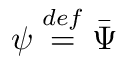<formula> <loc_0><loc_0><loc_500><loc_500>\psi { \stackrel { \ r { d e f } } { = } } \bar { \Psi }</formula> 